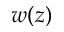<formula> <loc_0><loc_0><loc_500><loc_500>w ( z )</formula> 